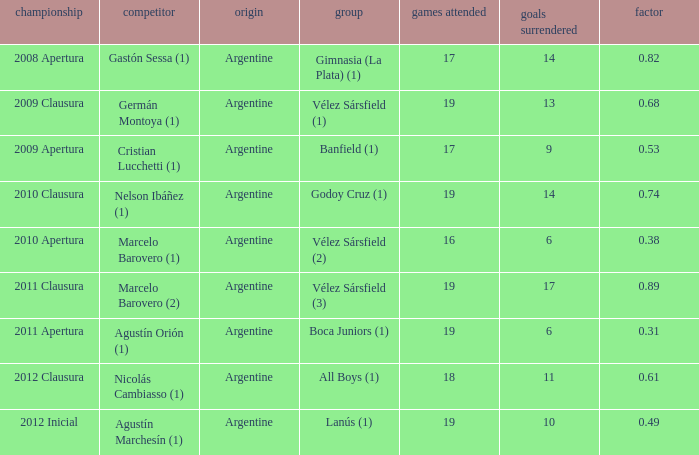What is the coefficient for agustín marchesín (1)? 0.49. 